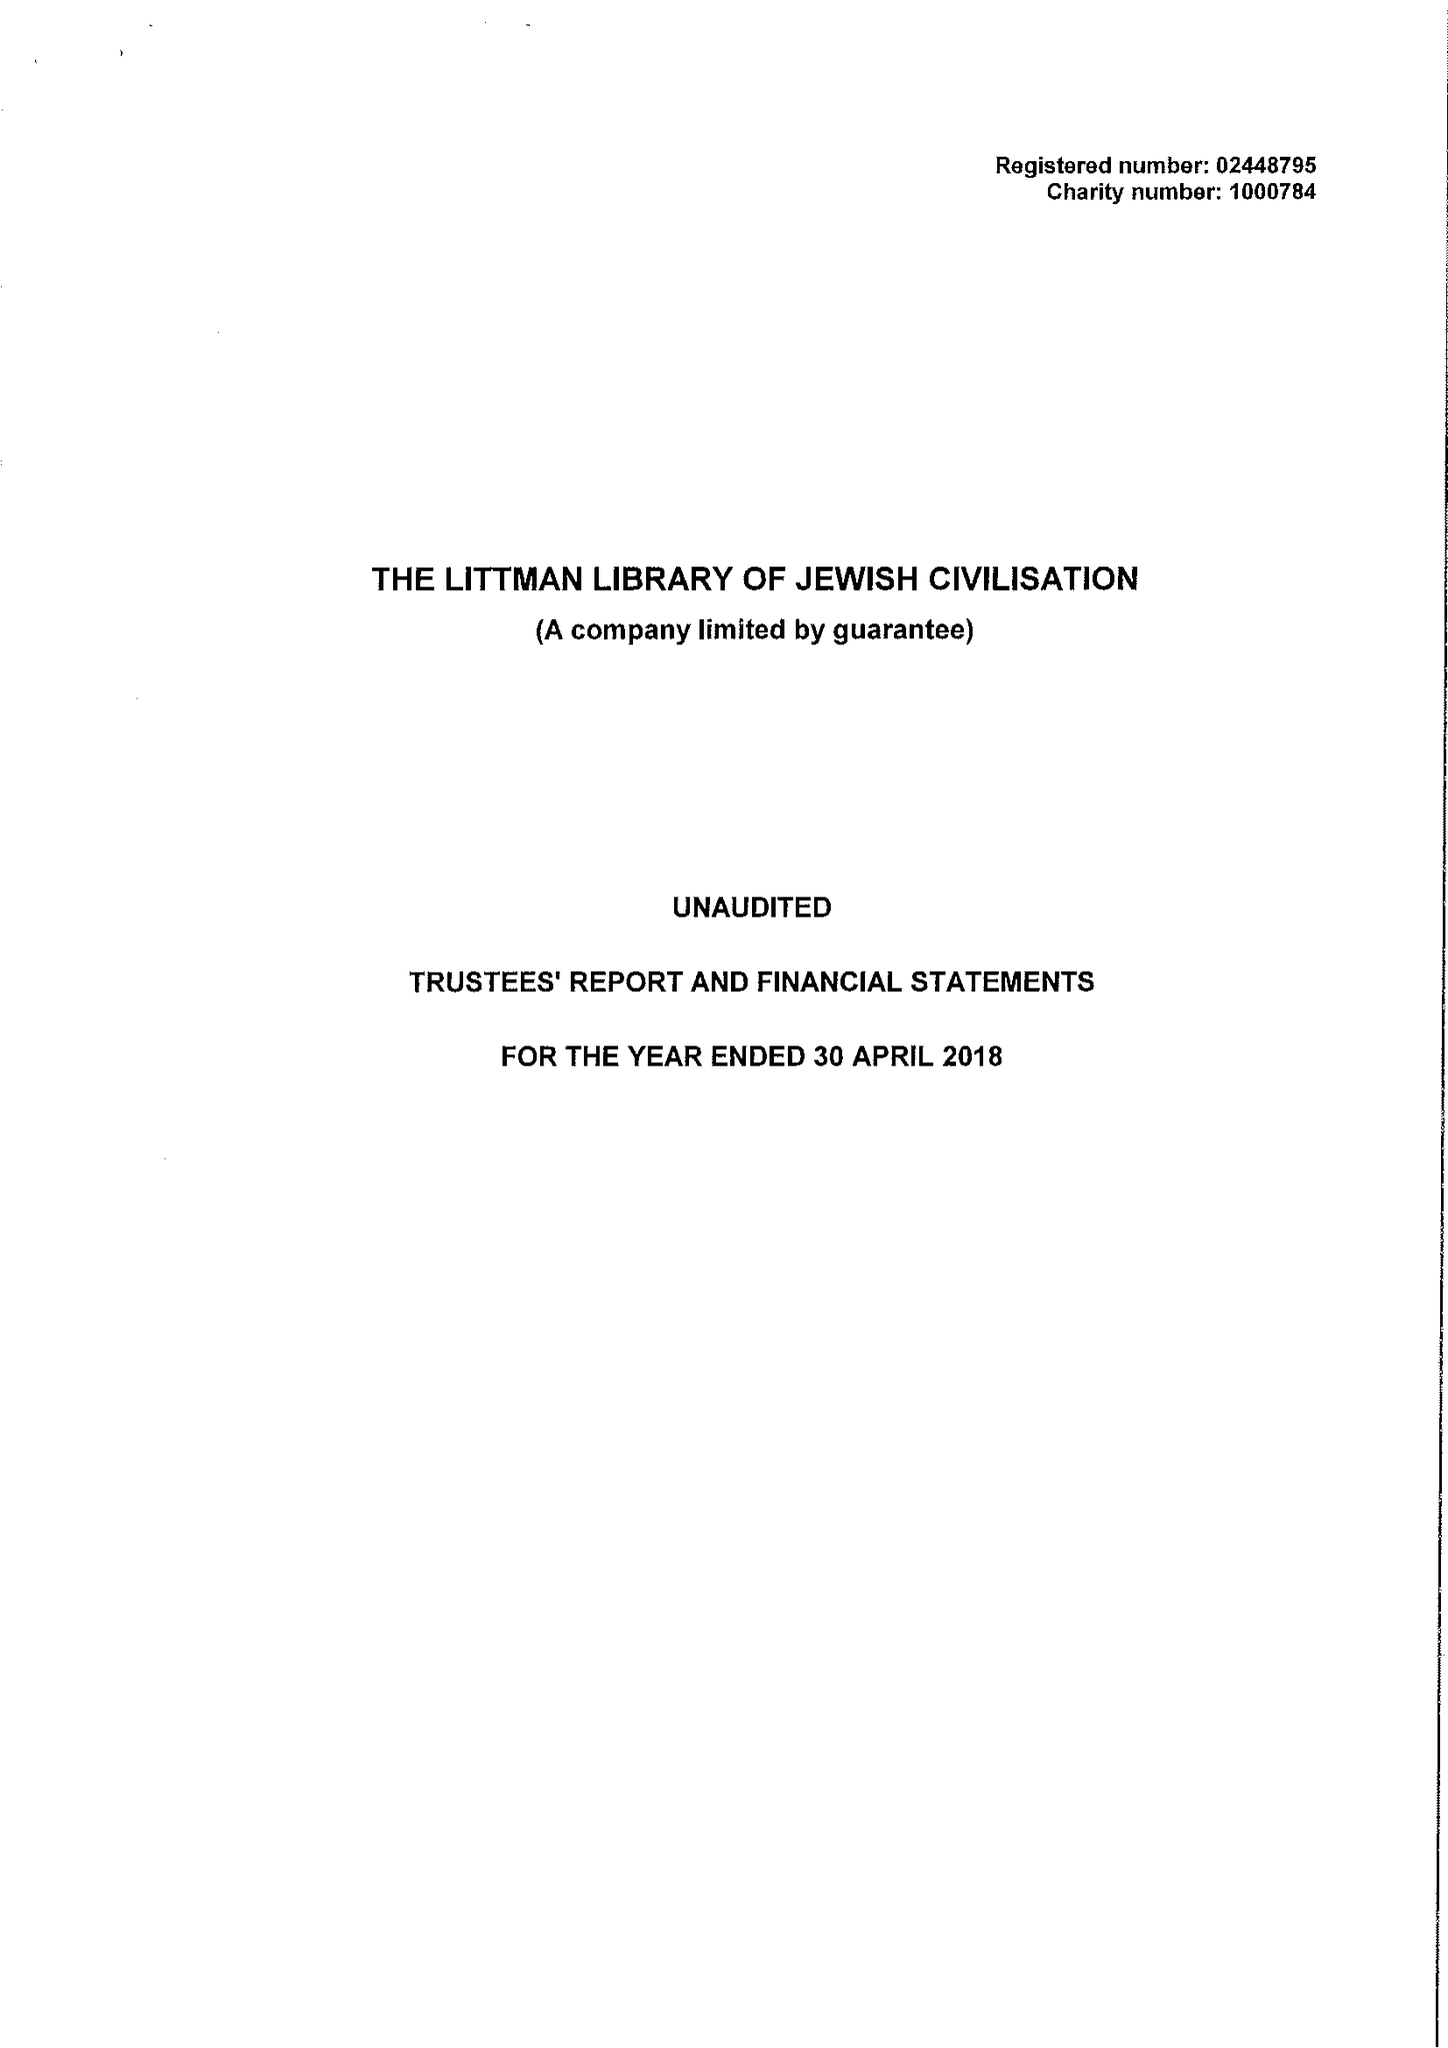What is the value for the spending_annually_in_british_pounds?
Answer the question using a single word or phrase. 495910.00 